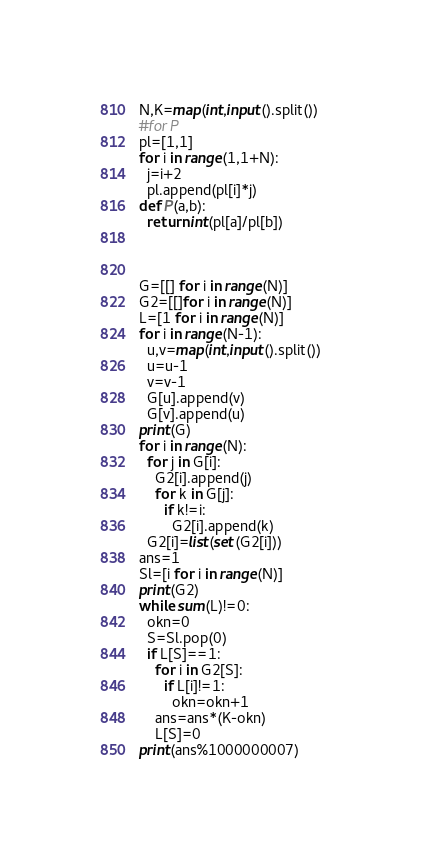<code> <loc_0><loc_0><loc_500><loc_500><_Python_>N,K=map(int,input().split())
#for P
pl=[1,1]
for i in range(1,1+N):
  j=i+2
  pl.append(pl[i]*j)
def P(a,b):
  return int(pl[a]/pl[b])

  

G=[[] for i in range(N)]
G2=[[]for i in range(N)]
L=[1 for i in range(N)]
for i in range(N-1):
  u,v=map(int,input().split())
  u=u-1
  v=v-1
  G[u].append(v)
  G[v].append(u)
print(G)
for i in range(N):
  for j in G[i]:
    G2[i].append(j)
    for k in G[j]:
      if k!=i:
        G2[i].append(k)
  G2[i]=list(set(G2[i]))
ans=1
Sl=[i for i in range(N)]
print(G2)
while sum(L)!=0:
  okn=0
  S=Sl.pop(0)
  if L[S]==1:
    for i in G2[S]:
      if L[i]!=1:
        okn=okn+1
    ans=ans*(K-okn)
    L[S]=0
print(ans%1000000007)</code> 